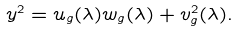<formula> <loc_0><loc_0><loc_500><loc_500>y ^ { 2 } = u _ { g } ( \lambda ) w _ { g } ( \lambda ) + v _ { g } ^ { 2 } ( \lambda ) .</formula> 